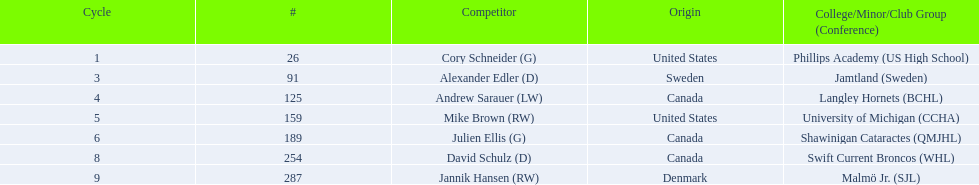What are the names of the colleges and jr leagues the players attended? Phillips Academy (US High School), Jamtland (Sweden), Langley Hornets (BCHL), University of Michigan (CCHA), Shawinigan Cataractes (QMJHL), Swift Current Broncos (WHL), Malmö Jr. (SJL). Which player played for the langley hornets? Andrew Sarauer (LW). 